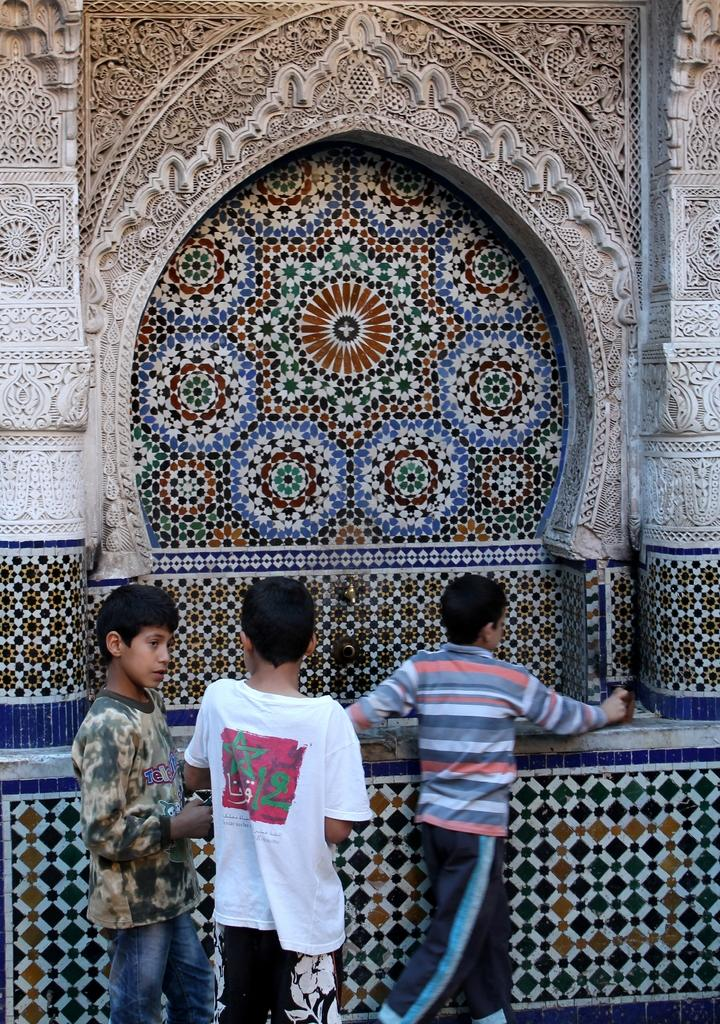How many boys are in the image? There are three small boys in the image. Where are the boys positioned in the image? The boys are standing in the front. What architectural feature can be seen in the image? There is a beautiful design arch in the image. What type of material is present in the image? Cladding tiles are present in the image. What is the manager saying to the boys in the image? There is no manager present in the image, so it is not possible to determine what the manager might be saying to the boys. 